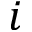Convert formula to latex. <formula><loc_0><loc_0><loc_500><loc_500>i</formula> 